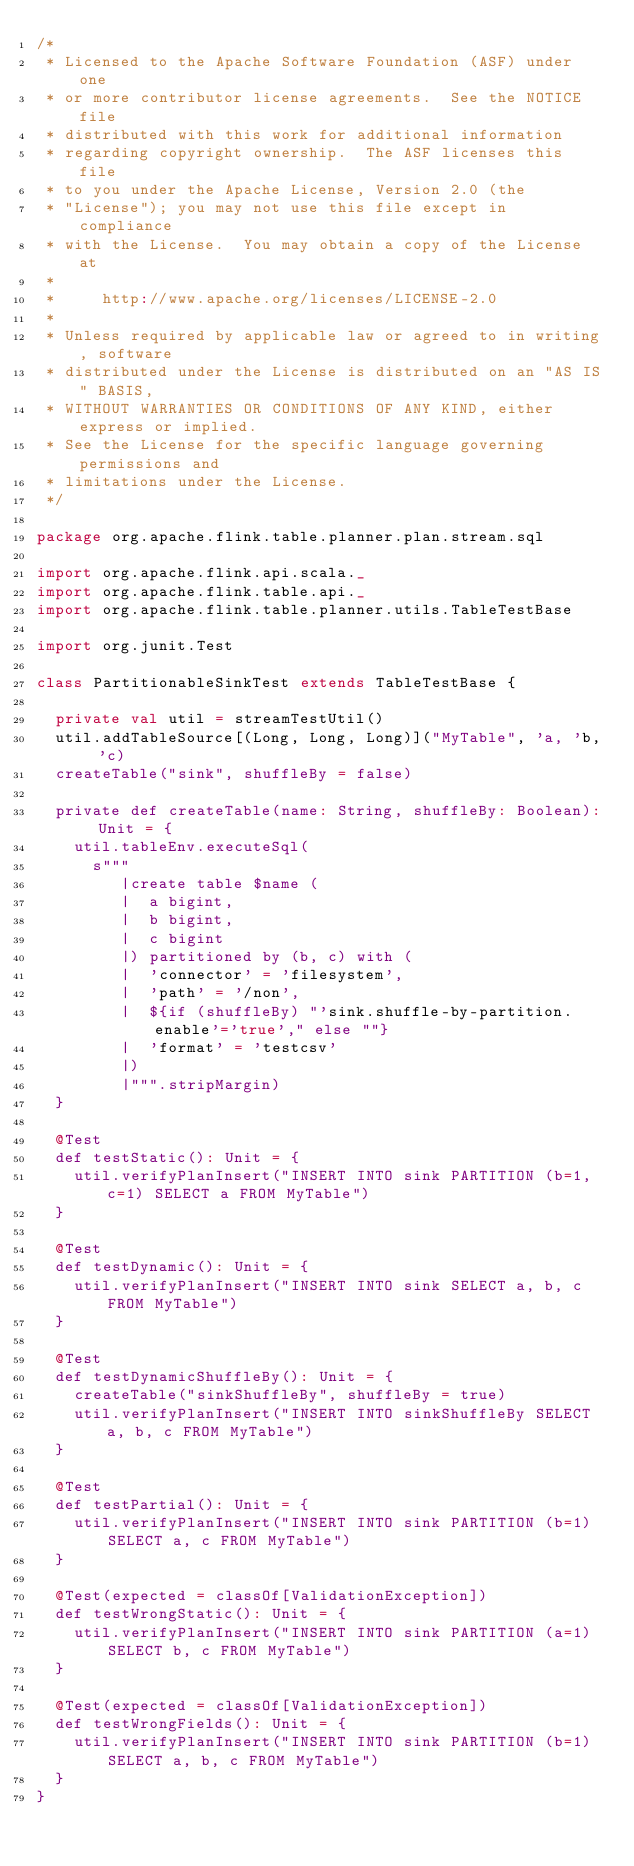<code> <loc_0><loc_0><loc_500><loc_500><_Scala_>/*
 * Licensed to the Apache Software Foundation (ASF) under one
 * or more contributor license agreements.  See the NOTICE file
 * distributed with this work for additional information
 * regarding copyright ownership.  The ASF licenses this file
 * to you under the Apache License, Version 2.0 (the
 * "License"); you may not use this file except in compliance
 * with the License.  You may obtain a copy of the License at
 *
 *     http://www.apache.org/licenses/LICENSE-2.0
 *
 * Unless required by applicable law or agreed to in writing, software
 * distributed under the License is distributed on an "AS IS" BASIS,
 * WITHOUT WARRANTIES OR CONDITIONS OF ANY KIND, either express or implied.
 * See the License for the specific language governing permissions and
 * limitations under the License.
 */

package org.apache.flink.table.planner.plan.stream.sql

import org.apache.flink.api.scala._
import org.apache.flink.table.api._
import org.apache.flink.table.planner.utils.TableTestBase

import org.junit.Test

class PartitionableSinkTest extends TableTestBase {

  private val util = streamTestUtil()
  util.addTableSource[(Long, Long, Long)]("MyTable", 'a, 'b, 'c)
  createTable("sink", shuffleBy = false)

  private def createTable(name: String, shuffleBy: Boolean): Unit = {
    util.tableEnv.executeSql(
      s"""
         |create table $name (
         |  a bigint,
         |  b bigint,
         |  c bigint
         |) partitioned by (b, c) with (
         |  'connector' = 'filesystem',
         |  'path' = '/non',
         |  ${if (shuffleBy) "'sink.shuffle-by-partition.enable'='true'," else ""}
         |  'format' = 'testcsv'
         |)
         |""".stripMargin)
  }

  @Test
  def testStatic(): Unit = {
    util.verifyPlanInsert("INSERT INTO sink PARTITION (b=1, c=1) SELECT a FROM MyTable")
  }

  @Test
  def testDynamic(): Unit = {
    util.verifyPlanInsert("INSERT INTO sink SELECT a, b, c FROM MyTable")
  }

  @Test
  def testDynamicShuffleBy(): Unit = {
    createTable("sinkShuffleBy", shuffleBy = true)
    util.verifyPlanInsert("INSERT INTO sinkShuffleBy SELECT a, b, c FROM MyTable")
  }

  @Test
  def testPartial(): Unit = {
    util.verifyPlanInsert("INSERT INTO sink PARTITION (b=1) SELECT a, c FROM MyTable")
  }

  @Test(expected = classOf[ValidationException])
  def testWrongStatic(): Unit = {
    util.verifyPlanInsert("INSERT INTO sink PARTITION (a=1) SELECT b, c FROM MyTable")
  }

  @Test(expected = classOf[ValidationException])
  def testWrongFields(): Unit = {
    util.verifyPlanInsert("INSERT INTO sink PARTITION (b=1) SELECT a, b, c FROM MyTable")
  }
}
</code> 